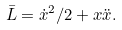Convert formula to latex. <formula><loc_0><loc_0><loc_500><loc_500>\bar { L } = \dot { x } ^ { 2 } / 2 + x \ddot { x } .</formula> 